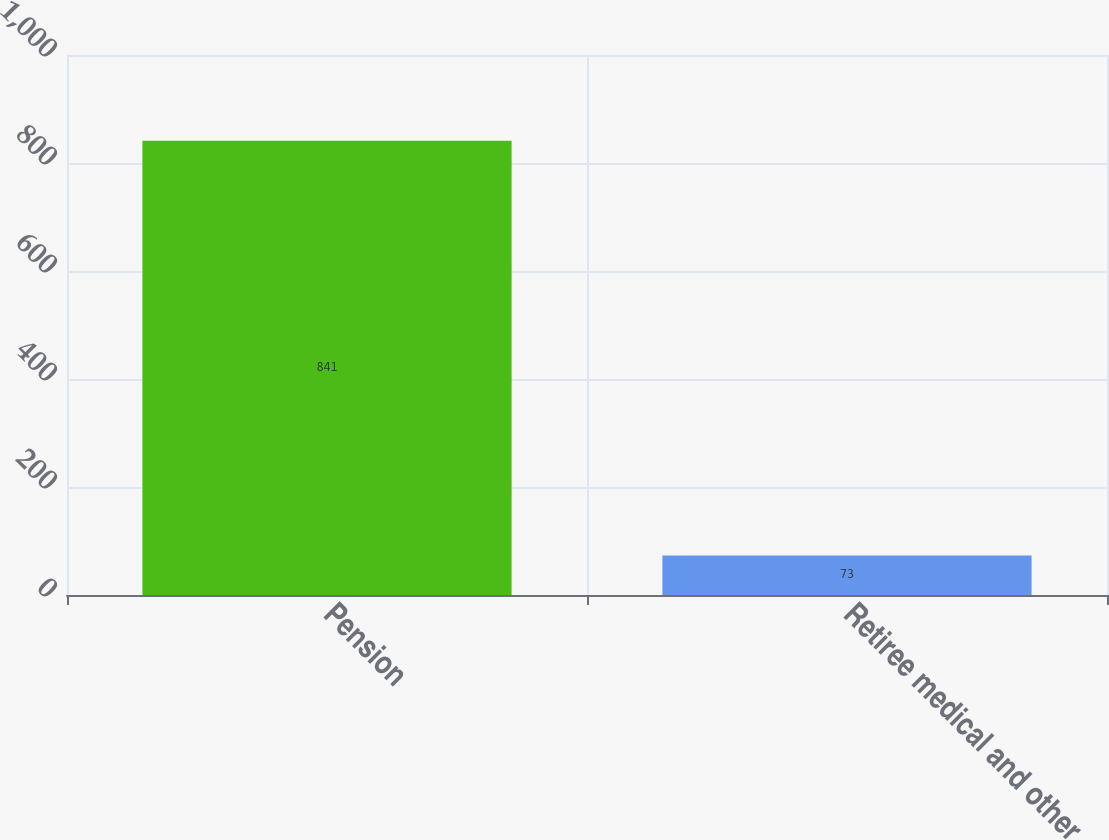<chart> <loc_0><loc_0><loc_500><loc_500><bar_chart><fcel>Pension<fcel>Retiree medical and other<nl><fcel>841<fcel>73<nl></chart> 